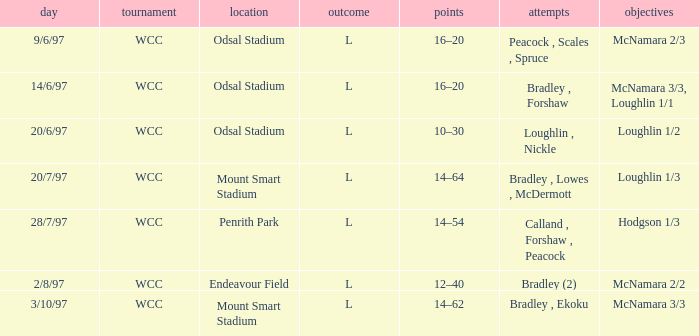What were the goals on 3/10/97? McNamara 3/3. 